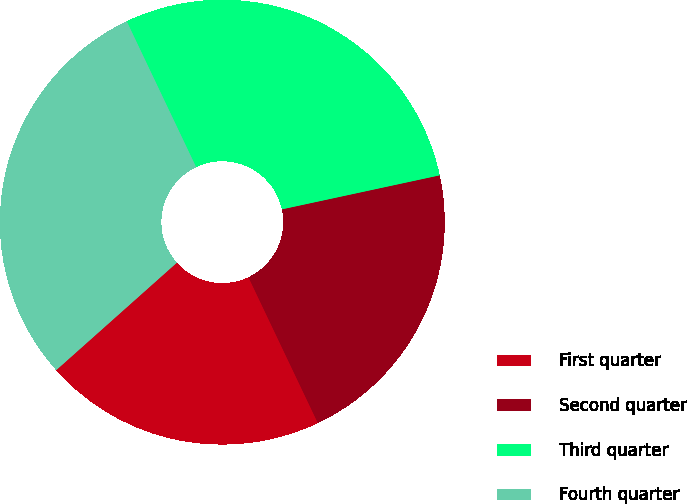<chart> <loc_0><loc_0><loc_500><loc_500><pie_chart><fcel>First quarter<fcel>Second quarter<fcel>Third quarter<fcel>Fourth quarter<nl><fcel>20.49%<fcel>21.31%<fcel>28.69%<fcel>29.51%<nl></chart> 